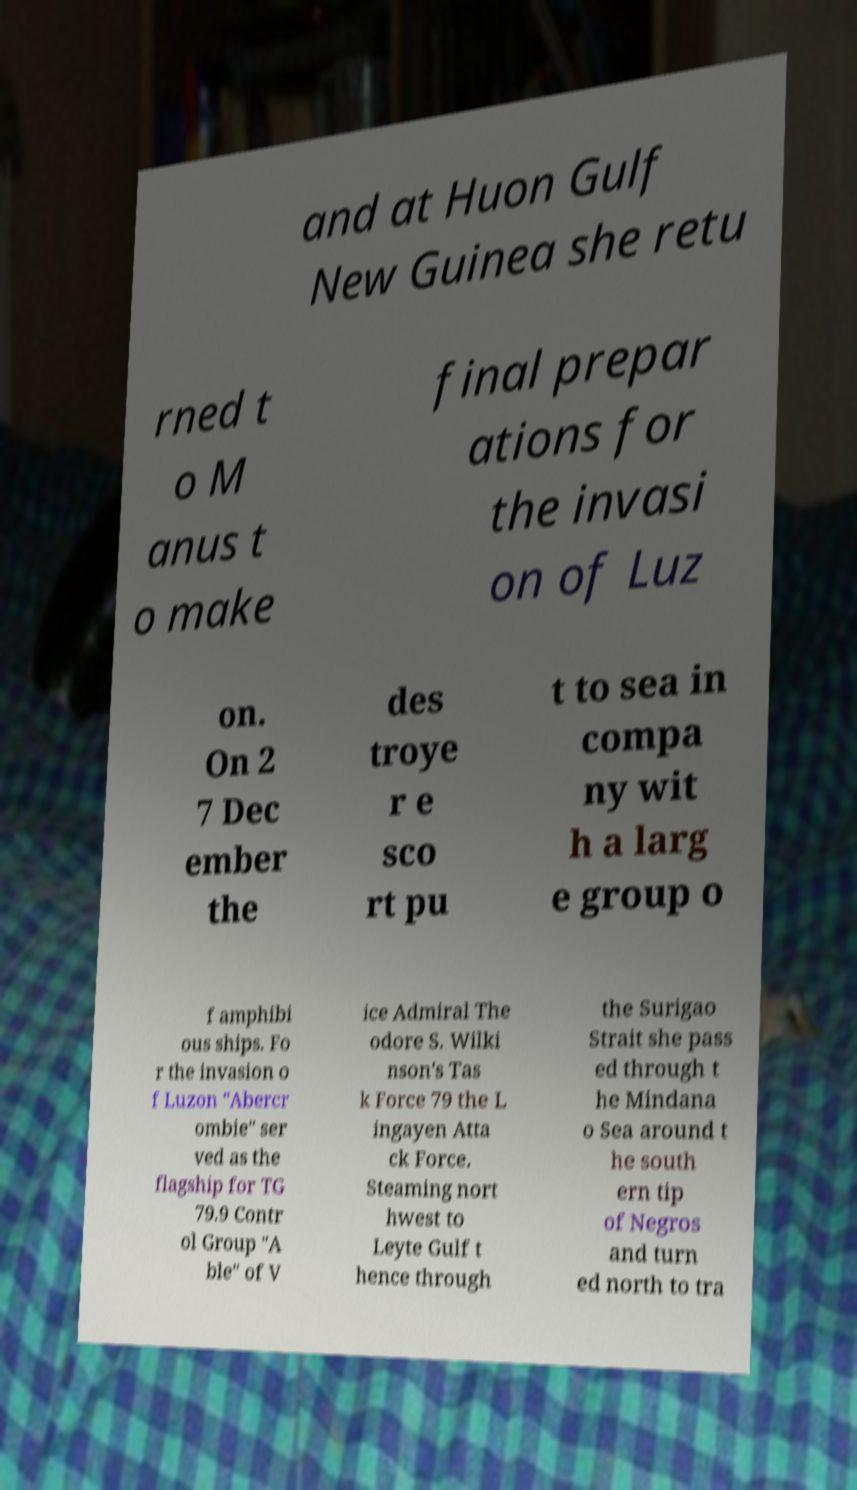Can you read and provide the text displayed in the image?This photo seems to have some interesting text. Can you extract and type it out for me? and at Huon Gulf New Guinea she retu rned t o M anus t o make final prepar ations for the invasi on of Luz on. On 2 7 Dec ember the des troye r e sco rt pu t to sea in compa ny wit h a larg e group o f amphibi ous ships. Fo r the invasion o f Luzon "Abercr ombie" ser ved as the flagship for TG 79.9 Contr ol Group "A ble" of V ice Admiral The odore S. Wilki nson's Tas k Force 79 the L ingayen Atta ck Force. Steaming nort hwest to Leyte Gulf t hence through the Surigao Strait she pass ed through t he Mindana o Sea around t he south ern tip of Negros and turn ed north to tra 